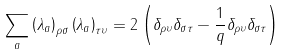<formula> <loc_0><loc_0><loc_500><loc_500>\sum _ { a } \left ( \lambda _ { a } \right ) _ { \rho \sigma } \left ( \lambda _ { a } \right ) _ { \tau \upsilon } = 2 \left ( \delta _ { \rho \upsilon } \delta _ { \sigma \tau } - \frac { 1 } { q } \delta _ { \rho \upsilon } \delta _ { \sigma \tau } \right )</formula> 